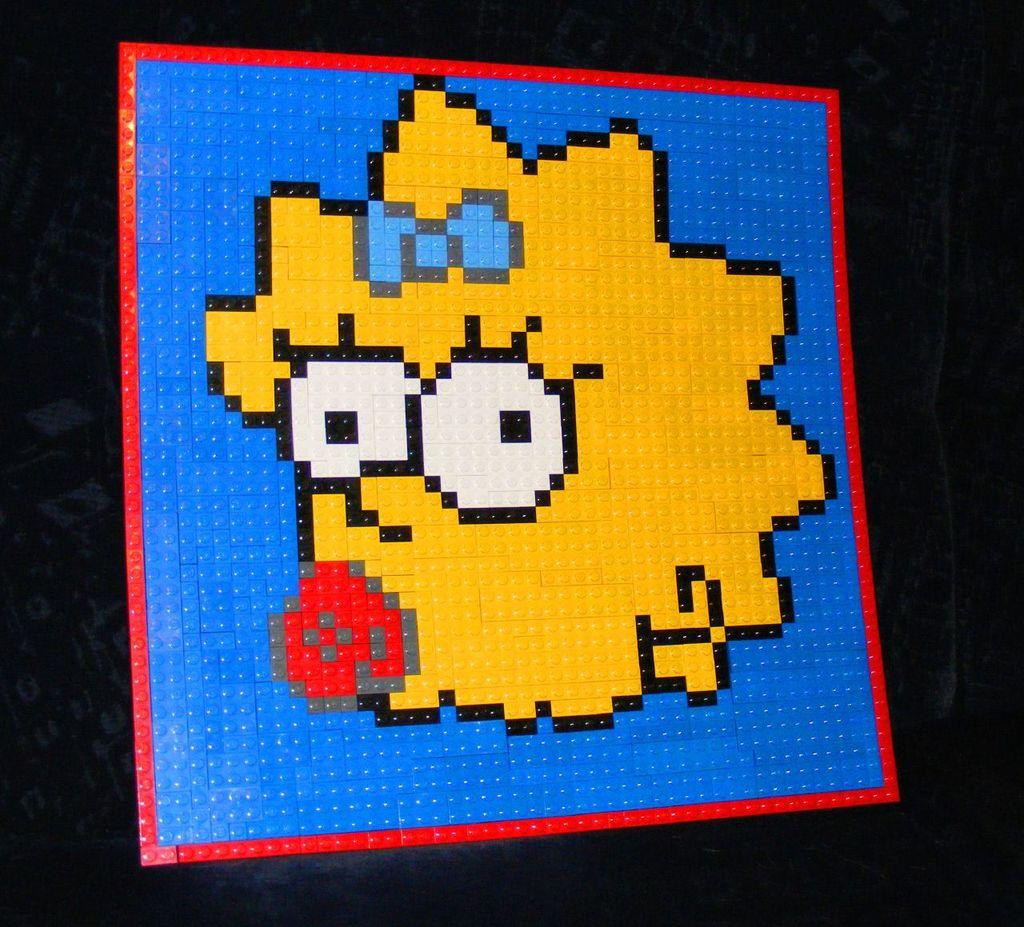What type of puzzle is depicted in the image? The image contains a lego puzzle. What kind of image is featured in the lego puzzle? The lego puzzle is of a cartoon picture. What colors are used in the lego puzzle? The colors in the lego puzzle include yellow, red, and white. What color are the borders of the lego puzzle? The borders of the lego puzzle are blue. Can you see any snails crawling on the lego puzzle in the image? There are no snails present in the image; it features a lego puzzle with a cartoon picture. Is there a flight taking off in the background of the image? There is no flight or any reference to a flight in the image; it only contains a lego puzzle. 